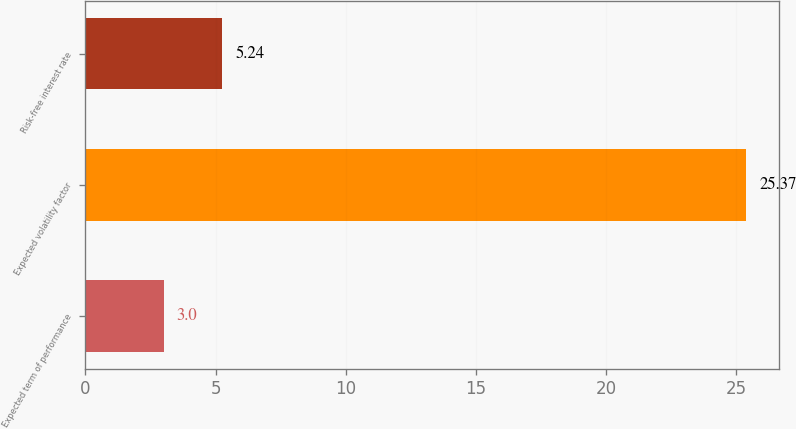<chart> <loc_0><loc_0><loc_500><loc_500><bar_chart><fcel>Expected term of performance<fcel>Expected volatility factor<fcel>Risk-free interest rate<nl><fcel>3<fcel>25.37<fcel>5.24<nl></chart> 